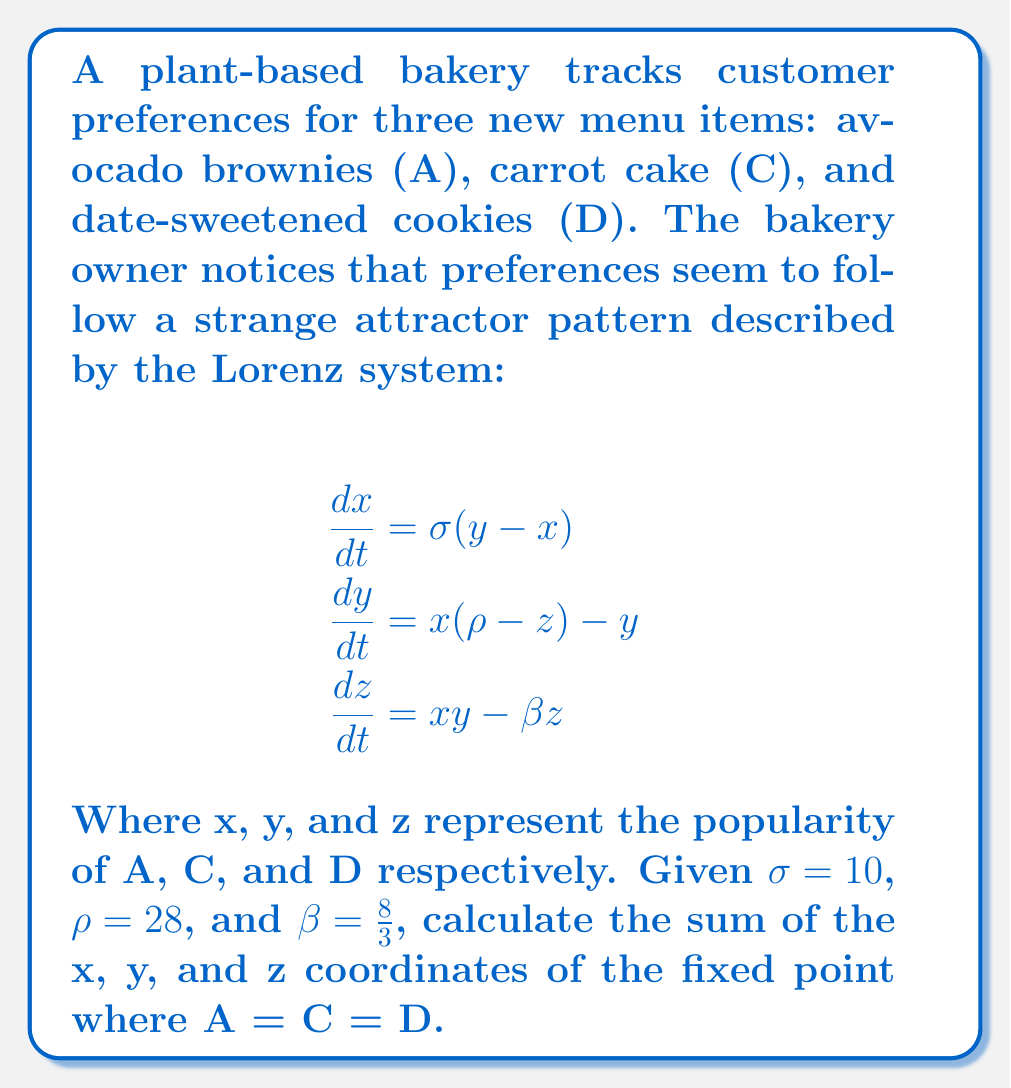Could you help me with this problem? To solve this problem, we need to find the fixed point of the Lorenz system where all three variables are equal. At a fixed point, the rates of change are zero:

1) Set all derivatives to zero:
   $$\frac{dx}{dt} = \frac{dy}{dt} = \frac{dz}{dt} = 0$$

2) Substitute the given values and let x = y = z:
   $$0 = 10(x - x) = 0$$
   $$0 = x(28 - x) - x$$
   $$0 = x^2 - \frac{8}{3}x$$

3) Solve the quadratic equation:
   $$x^2 - \frac{8}{3}x = 0$$
   $$x(x - \frac{8}{3}) = 0$$

4) The solutions are x = 0 or x = 8/3. Since we're looking for the non-zero fixed point:
   $$x = y = z = \frac{8}{3}$$

5) Sum the coordinates:
   $$\text{Sum} = x + y + z = \frac{8}{3} + \frac{8}{3} + \frac{8}{3} = 8$$
Answer: 8 